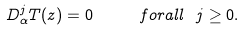Convert formula to latex. <formula><loc_0><loc_0><loc_500><loc_500>D ^ { j } _ { \alpha } T ( z ) = 0 \quad \ f o r a l l \ j \geq 0 .</formula> 